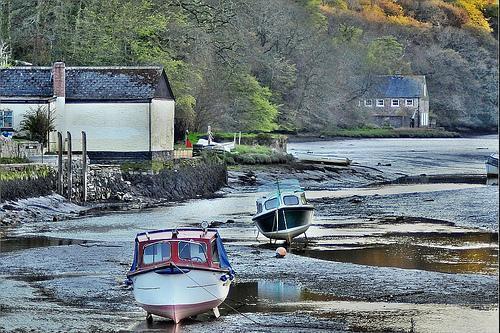How many boats are there?
Give a very brief answer. 3. How many windows in the home?
Give a very brief answer. 5. How many colors is the first boat?
Give a very brief answer. 4. How many chimneys are there?
Give a very brief answer. 1. 